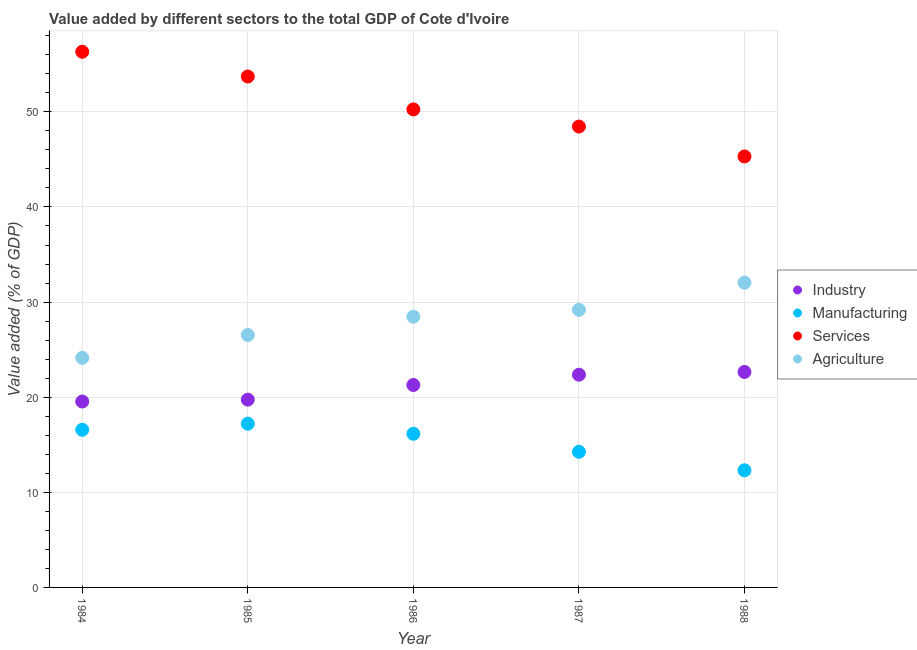What is the value added by industrial sector in 1986?
Your answer should be compact. 21.28. Across all years, what is the maximum value added by manufacturing sector?
Your response must be concise. 17.21. Across all years, what is the minimum value added by services sector?
Offer a very short reply. 45.31. What is the total value added by agricultural sector in the graph?
Your answer should be very brief. 140.36. What is the difference between the value added by services sector in 1985 and that in 1987?
Your answer should be very brief. 5.26. What is the difference between the value added by agricultural sector in 1986 and the value added by services sector in 1984?
Keep it short and to the point. -27.86. What is the average value added by agricultural sector per year?
Make the answer very short. 28.07. In the year 1988, what is the difference between the value added by industrial sector and value added by agricultural sector?
Your response must be concise. -9.39. What is the ratio of the value added by agricultural sector in 1986 to that in 1988?
Your response must be concise. 0.89. Is the difference between the value added by manufacturing sector in 1985 and 1987 greater than the difference between the value added by services sector in 1985 and 1987?
Ensure brevity in your answer.  No. What is the difference between the highest and the second highest value added by agricultural sector?
Your answer should be compact. 2.86. What is the difference between the highest and the lowest value added by industrial sector?
Give a very brief answer. 3.1. In how many years, is the value added by agricultural sector greater than the average value added by agricultural sector taken over all years?
Provide a short and direct response. 3. Is it the case that in every year, the sum of the value added by industrial sector and value added by agricultural sector is greater than the sum of value added by services sector and value added by manufacturing sector?
Your answer should be very brief. No. Is the value added by agricultural sector strictly greater than the value added by manufacturing sector over the years?
Give a very brief answer. Yes. How many dotlines are there?
Provide a succinct answer. 4. Are the values on the major ticks of Y-axis written in scientific E-notation?
Provide a short and direct response. No. Does the graph contain any zero values?
Your answer should be very brief. No. Where does the legend appear in the graph?
Provide a short and direct response. Center right. How are the legend labels stacked?
Provide a succinct answer. Vertical. What is the title of the graph?
Ensure brevity in your answer.  Value added by different sectors to the total GDP of Cote d'Ivoire. What is the label or title of the Y-axis?
Offer a very short reply. Value added (% of GDP). What is the Value added (% of GDP) of Industry in 1984?
Ensure brevity in your answer.  19.55. What is the Value added (% of GDP) of Manufacturing in 1984?
Keep it short and to the point. 16.57. What is the Value added (% of GDP) in Services in 1984?
Ensure brevity in your answer.  56.32. What is the Value added (% of GDP) of Agriculture in 1984?
Your answer should be very brief. 24.13. What is the Value added (% of GDP) in Industry in 1985?
Provide a short and direct response. 19.75. What is the Value added (% of GDP) in Manufacturing in 1985?
Keep it short and to the point. 17.21. What is the Value added (% of GDP) of Services in 1985?
Your answer should be very brief. 53.72. What is the Value added (% of GDP) in Agriculture in 1985?
Your response must be concise. 26.54. What is the Value added (% of GDP) in Industry in 1986?
Make the answer very short. 21.28. What is the Value added (% of GDP) in Manufacturing in 1986?
Your answer should be compact. 16.16. What is the Value added (% of GDP) in Services in 1986?
Make the answer very short. 50.26. What is the Value added (% of GDP) in Agriculture in 1986?
Provide a short and direct response. 28.46. What is the Value added (% of GDP) of Industry in 1987?
Make the answer very short. 22.36. What is the Value added (% of GDP) in Manufacturing in 1987?
Give a very brief answer. 14.26. What is the Value added (% of GDP) of Services in 1987?
Provide a succinct answer. 48.45. What is the Value added (% of GDP) of Agriculture in 1987?
Give a very brief answer. 29.18. What is the Value added (% of GDP) in Industry in 1988?
Keep it short and to the point. 22.65. What is the Value added (% of GDP) of Manufacturing in 1988?
Make the answer very short. 12.32. What is the Value added (% of GDP) of Services in 1988?
Your answer should be very brief. 45.31. What is the Value added (% of GDP) of Agriculture in 1988?
Make the answer very short. 32.04. Across all years, what is the maximum Value added (% of GDP) of Industry?
Provide a succinct answer. 22.65. Across all years, what is the maximum Value added (% of GDP) of Manufacturing?
Your answer should be compact. 17.21. Across all years, what is the maximum Value added (% of GDP) of Services?
Make the answer very short. 56.32. Across all years, what is the maximum Value added (% of GDP) in Agriculture?
Your response must be concise. 32.04. Across all years, what is the minimum Value added (% of GDP) in Industry?
Offer a terse response. 19.55. Across all years, what is the minimum Value added (% of GDP) in Manufacturing?
Provide a succinct answer. 12.32. Across all years, what is the minimum Value added (% of GDP) of Services?
Your response must be concise. 45.31. Across all years, what is the minimum Value added (% of GDP) of Agriculture?
Give a very brief answer. 24.13. What is the total Value added (% of GDP) in Industry in the graph?
Ensure brevity in your answer.  105.59. What is the total Value added (% of GDP) of Manufacturing in the graph?
Ensure brevity in your answer.  76.52. What is the total Value added (% of GDP) of Services in the graph?
Your answer should be very brief. 254.05. What is the total Value added (% of GDP) in Agriculture in the graph?
Your answer should be compact. 140.36. What is the difference between the Value added (% of GDP) in Industry in 1984 and that in 1985?
Your response must be concise. -0.2. What is the difference between the Value added (% of GDP) of Manufacturing in 1984 and that in 1985?
Your answer should be compact. -0.64. What is the difference between the Value added (% of GDP) in Services in 1984 and that in 1985?
Make the answer very short. 2.6. What is the difference between the Value added (% of GDP) in Agriculture in 1984 and that in 1985?
Your response must be concise. -2.4. What is the difference between the Value added (% of GDP) of Industry in 1984 and that in 1986?
Keep it short and to the point. -1.73. What is the difference between the Value added (% of GDP) of Manufacturing in 1984 and that in 1986?
Provide a short and direct response. 0.42. What is the difference between the Value added (% of GDP) of Services in 1984 and that in 1986?
Give a very brief answer. 6.06. What is the difference between the Value added (% of GDP) of Agriculture in 1984 and that in 1986?
Offer a very short reply. -4.33. What is the difference between the Value added (% of GDP) of Industry in 1984 and that in 1987?
Offer a terse response. -2.82. What is the difference between the Value added (% of GDP) in Manufacturing in 1984 and that in 1987?
Offer a terse response. 2.32. What is the difference between the Value added (% of GDP) of Services in 1984 and that in 1987?
Your answer should be compact. 7.86. What is the difference between the Value added (% of GDP) in Agriculture in 1984 and that in 1987?
Make the answer very short. -5.05. What is the difference between the Value added (% of GDP) in Industry in 1984 and that in 1988?
Your answer should be compact. -3.1. What is the difference between the Value added (% of GDP) in Manufacturing in 1984 and that in 1988?
Keep it short and to the point. 4.26. What is the difference between the Value added (% of GDP) of Services in 1984 and that in 1988?
Provide a short and direct response. 11.01. What is the difference between the Value added (% of GDP) in Agriculture in 1984 and that in 1988?
Your response must be concise. -7.9. What is the difference between the Value added (% of GDP) in Industry in 1985 and that in 1986?
Your answer should be compact. -1.54. What is the difference between the Value added (% of GDP) of Manufacturing in 1985 and that in 1986?
Your answer should be compact. 1.05. What is the difference between the Value added (% of GDP) of Services in 1985 and that in 1986?
Your answer should be compact. 3.46. What is the difference between the Value added (% of GDP) of Agriculture in 1985 and that in 1986?
Your response must be concise. -1.92. What is the difference between the Value added (% of GDP) of Industry in 1985 and that in 1987?
Provide a succinct answer. -2.62. What is the difference between the Value added (% of GDP) of Manufacturing in 1985 and that in 1987?
Your response must be concise. 2.95. What is the difference between the Value added (% of GDP) of Services in 1985 and that in 1987?
Your answer should be compact. 5.26. What is the difference between the Value added (% of GDP) in Agriculture in 1985 and that in 1987?
Offer a terse response. -2.64. What is the difference between the Value added (% of GDP) in Industry in 1985 and that in 1988?
Make the answer very short. -2.9. What is the difference between the Value added (% of GDP) in Manufacturing in 1985 and that in 1988?
Your answer should be compact. 4.9. What is the difference between the Value added (% of GDP) in Services in 1985 and that in 1988?
Ensure brevity in your answer.  8.41. What is the difference between the Value added (% of GDP) of Agriculture in 1985 and that in 1988?
Give a very brief answer. -5.5. What is the difference between the Value added (% of GDP) in Industry in 1986 and that in 1987?
Offer a very short reply. -1.08. What is the difference between the Value added (% of GDP) in Manufacturing in 1986 and that in 1987?
Your answer should be very brief. 1.9. What is the difference between the Value added (% of GDP) of Services in 1986 and that in 1987?
Your answer should be very brief. 1.8. What is the difference between the Value added (% of GDP) of Agriculture in 1986 and that in 1987?
Your response must be concise. -0.72. What is the difference between the Value added (% of GDP) in Industry in 1986 and that in 1988?
Make the answer very short. -1.37. What is the difference between the Value added (% of GDP) in Manufacturing in 1986 and that in 1988?
Your response must be concise. 3.84. What is the difference between the Value added (% of GDP) of Services in 1986 and that in 1988?
Give a very brief answer. 4.95. What is the difference between the Value added (% of GDP) in Agriculture in 1986 and that in 1988?
Provide a succinct answer. -3.58. What is the difference between the Value added (% of GDP) of Industry in 1987 and that in 1988?
Your answer should be very brief. -0.29. What is the difference between the Value added (% of GDP) in Manufacturing in 1987 and that in 1988?
Give a very brief answer. 1.94. What is the difference between the Value added (% of GDP) in Services in 1987 and that in 1988?
Keep it short and to the point. 3.14. What is the difference between the Value added (% of GDP) in Agriculture in 1987 and that in 1988?
Your answer should be compact. -2.86. What is the difference between the Value added (% of GDP) of Industry in 1984 and the Value added (% of GDP) of Manufacturing in 1985?
Offer a terse response. 2.34. What is the difference between the Value added (% of GDP) in Industry in 1984 and the Value added (% of GDP) in Services in 1985?
Ensure brevity in your answer.  -34.17. What is the difference between the Value added (% of GDP) in Industry in 1984 and the Value added (% of GDP) in Agriculture in 1985?
Provide a succinct answer. -6.99. What is the difference between the Value added (% of GDP) in Manufacturing in 1984 and the Value added (% of GDP) in Services in 1985?
Give a very brief answer. -37.14. What is the difference between the Value added (% of GDP) in Manufacturing in 1984 and the Value added (% of GDP) in Agriculture in 1985?
Offer a terse response. -9.96. What is the difference between the Value added (% of GDP) of Services in 1984 and the Value added (% of GDP) of Agriculture in 1985?
Your response must be concise. 29.78. What is the difference between the Value added (% of GDP) of Industry in 1984 and the Value added (% of GDP) of Manufacturing in 1986?
Make the answer very short. 3.39. What is the difference between the Value added (% of GDP) of Industry in 1984 and the Value added (% of GDP) of Services in 1986?
Keep it short and to the point. -30.71. What is the difference between the Value added (% of GDP) of Industry in 1984 and the Value added (% of GDP) of Agriculture in 1986?
Your response must be concise. -8.91. What is the difference between the Value added (% of GDP) in Manufacturing in 1984 and the Value added (% of GDP) in Services in 1986?
Your answer should be very brief. -33.68. What is the difference between the Value added (% of GDP) of Manufacturing in 1984 and the Value added (% of GDP) of Agriculture in 1986?
Keep it short and to the point. -11.89. What is the difference between the Value added (% of GDP) of Services in 1984 and the Value added (% of GDP) of Agriculture in 1986?
Ensure brevity in your answer.  27.86. What is the difference between the Value added (% of GDP) of Industry in 1984 and the Value added (% of GDP) of Manufacturing in 1987?
Keep it short and to the point. 5.29. What is the difference between the Value added (% of GDP) of Industry in 1984 and the Value added (% of GDP) of Services in 1987?
Make the answer very short. -28.9. What is the difference between the Value added (% of GDP) in Industry in 1984 and the Value added (% of GDP) in Agriculture in 1987?
Give a very brief answer. -9.63. What is the difference between the Value added (% of GDP) in Manufacturing in 1984 and the Value added (% of GDP) in Services in 1987?
Provide a succinct answer. -31.88. What is the difference between the Value added (% of GDP) of Manufacturing in 1984 and the Value added (% of GDP) of Agriculture in 1987?
Keep it short and to the point. -12.61. What is the difference between the Value added (% of GDP) of Services in 1984 and the Value added (% of GDP) of Agriculture in 1987?
Give a very brief answer. 27.13. What is the difference between the Value added (% of GDP) in Industry in 1984 and the Value added (% of GDP) in Manufacturing in 1988?
Offer a terse response. 7.23. What is the difference between the Value added (% of GDP) of Industry in 1984 and the Value added (% of GDP) of Services in 1988?
Your answer should be compact. -25.76. What is the difference between the Value added (% of GDP) in Industry in 1984 and the Value added (% of GDP) in Agriculture in 1988?
Keep it short and to the point. -12.49. What is the difference between the Value added (% of GDP) in Manufacturing in 1984 and the Value added (% of GDP) in Services in 1988?
Provide a short and direct response. -28.74. What is the difference between the Value added (% of GDP) in Manufacturing in 1984 and the Value added (% of GDP) in Agriculture in 1988?
Provide a succinct answer. -15.47. What is the difference between the Value added (% of GDP) of Services in 1984 and the Value added (% of GDP) of Agriculture in 1988?
Provide a short and direct response. 24.28. What is the difference between the Value added (% of GDP) in Industry in 1985 and the Value added (% of GDP) in Manufacturing in 1986?
Provide a succinct answer. 3.59. What is the difference between the Value added (% of GDP) of Industry in 1985 and the Value added (% of GDP) of Services in 1986?
Provide a succinct answer. -30.51. What is the difference between the Value added (% of GDP) of Industry in 1985 and the Value added (% of GDP) of Agriculture in 1986?
Your response must be concise. -8.72. What is the difference between the Value added (% of GDP) of Manufacturing in 1985 and the Value added (% of GDP) of Services in 1986?
Ensure brevity in your answer.  -33.04. What is the difference between the Value added (% of GDP) in Manufacturing in 1985 and the Value added (% of GDP) in Agriculture in 1986?
Make the answer very short. -11.25. What is the difference between the Value added (% of GDP) in Services in 1985 and the Value added (% of GDP) in Agriculture in 1986?
Your answer should be very brief. 25.25. What is the difference between the Value added (% of GDP) of Industry in 1985 and the Value added (% of GDP) of Manufacturing in 1987?
Keep it short and to the point. 5.49. What is the difference between the Value added (% of GDP) of Industry in 1985 and the Value added (% of GDP) of Services in 1987?
Keep it short and to the point. -28.71. What is the difference between the Value added (% of GDP) in Industry in 1985 and the Value added (% of GDP) in Agriculture in 1987?
Offer a terse response. -9.44. What is the difference between the Value added (% of GDP) in Manufacturing in 1985 and the Value added (% of GDP) in Services in 1987?
Offer a terse response. -31.24. What is the difference between the Value added (% of GDP) of Manufacturing in 1985 and the Value added (% of GDP) of Agriculture in 1987?
Offer a very short reply. -11.97. What is the difference between the Value added (% of GDP) of Services in 1985 and the Value added (% of GDP) of Agriculture in 1987?
Keep it short and to the point. 24.53. What is the difference between the Value added (% of GDP) of Industry in 1985 and the Value added (% of GDP) of Manufacturing in 1988?
Offer a terse response. 7.43. What is the difference between the Value added (% of GDP) of Industry in 1985 and the Value added (% of GDP) of Services in 1988?
Give a very brief answer. -25.56. What is the difference between the Value added (% of GDP) of Industry in 1985 and the Value added (% of GDP) of Agriculture in 1988?
Provide a short and direct response. -12.29. What is the difference between the Value added (% of GDP) in Manufacturing in 1985 and the Value added (% of GDP) in Services in 1988?
Offer a very short reply. -28.1. What is the difference between the Value added (% of GDP) in Manufacturing in 1985 and the Value added (% of GDP) in Agriculture in 1988?
Your response must be concise. -14.83. What is the difference between the Value added (% of GDP) of Services in 1985 and the Value added (% of GDP) of Agriculture in 1988?
Keep it short and to the point. 21.68. What is the difference between the Value added (% of GDP) in Industry in 1986 and the Value added (% of GDP) in Manufacturing in 1987?
Give a very brief answer. 7.02. What is the difference between the Value added (% of GDP) of Industry in 1986 and the Value added (% of GDP) of Services in 1987?
Make the answer very short. -27.17. What is the difference between the Value added (% of GDP) in Industry in 1986 and the Value added (% of GDP) in Agriculture in 1987?
Ensure brevity in your answer.  -7.9. What is the difference between the Value added (% of GDP) of Manufacturing in 1986 and the Value added (% of GDP) of Services in 1987?
Your response must be concise. -32.3. What is the difference between the Value added (% of GDP) in Manufacturing in 1986 and the Value added (% of GDP) in Agriculture in 1987?
Provide a succinct answer. -13.02. What is the difference between the Value added (% of GDP) of Services in 1986 and the Value added (% of GDP) of Agriculture in 1987?
Your response must be concise. 21.07. What is the difference between the Value added (% of GDP) in Industry in 1986 and the Value added (% of GDP) in Manufacturing in 1988?
Offer a very short reply. 8.97. What is the difference between the Value added (% of GDP) in Industry in 1986 and the Value added (% of GDP) in Services in 1988?
Make the answer very short. -24.03. What is the difference between the Value added (% of GDP) in Industry in 1986 and the Value added (% of GDP) in Agriculture in 1988?
Offer a very short reply. -10.76. What is the difference between the Value added (% of GDP) in Manufacturing in 1986 and the Value added (% of GDP) in Services in 1988?
Provide a succinct answer. -29.15. What is the difference between the Value added (% of GDP) in Manufacturing in 1986 and the Value added (% of GDP) in Agriculture in 1988?
Offer a very short reply. -15.88. What is the difference between the Value added (% of GDP) in Services in 1986 and the Value added (% of GDP) in Agriculture in 1988?
Your answer should be compact. 18.22. What is the difference between the Value added (% of GDP) in Industry in 1987 and the Value added (% of GDP) in Manufacturing in 1988?
Your answer should be compact. 10.05. What is the difference between the Value added (% of GDP) in Industry in 1987 and the Value added (% of GDP) in Services in 1988?
Provide a short and direct response. -22.95. What is the difference between the Value added (% of GDP) of Industry in 1987 and the Value added (% of GDP) of Agriculture in 1988?
Your answer should be very brief. -9.67. What is the difference between the Value added (% of GDP) of Manufacturing in 1987 and the Value added (% of GDP) of Services in 1988?
Give a very brief answer. -31.05. What is the difference between the Value added (% of GDP) of Manufacturing in 1987 and the Value added (% of GDP) of Agriculture in 1988?
Your answer should be compact. -17.78. What is the difference between the Value added (% of GDP) in Services in 1987 and the Value added (% of GDP) in Agriculture in 1988?
Provide a short and direct response. 16.41. What is the average Value added (% of GDP) of Industry per year?
Ensure brevity in your answer.  21.12. What is the average Value added (% of GDP) in Manufacturing per year?
Offer a terse response. 15.3. What is the average Value added (% of GDP) in Services per year?
Your answer should be very brief. 50.81. What is the average Value added (% of GDP) of Agriculture per year?
Offer a terse response. 28.07. In the year 1984, what is the difference between the Value added (% of GDP) in Industry and Value added (% of GDP) in Manufacturing?
Provide a succinct answer. 2.97. In the year 1984, what is the difference between the Value added (% of GDP) of Industry and Value added (% of GDP) of Services?
Make the answer very short. -36.77. In the year 1984, what is the difference between the Value added (% of GDP) of Industry and Value added (% of GDP) of Agriculture?
Make the answer very short. -4.59. In the year 1984, what is the difference between the Value added (% of GDP) in Manufacturing and Value added (% of GDP) in Services?
Offer a terse response. -39.74. In the year 1984, what is the difference between the Value added (% of GDP) in Manufacturing and Value added (% of GDP) in Agriculture?
Make the answer very short. -7.56. In the year 1984, what is the difference between the Value added (% of GDP) in Services and Value added (% of GDP) in Agriculture?
Your response must be concise. 32.18. In the year 1985, what is the difference between the Value added (% of GDP) in Industry and Value added (% of GDP) in Manufacturing?
Ensure brevity in your answer.  2.53. In the year 1985, what is the difference between the Value added (% of GDP) in Industry and Value added (% of GDP) in Services?
Make the answer very short. -33.97. In the year 1985, what is the difference between the Value added (% of GDP) in Industry and Value added (% of GDP) in Agriculture?
Keep it short and to the point. -6.79. In the year 1985, what is the difference between the Value added (% of GDP) of Manufacturing and Value added (% of GDP) of Services?
Offer a terse response. -36.51. In the year 1985, what is the difference between the Value added (% of GDP) of Manufacturing and Value added (% of GDP) of Agriculture?
Offer a terse response. -9.33. In the year 1985, what is the difference between the Value added (% of GDP) of Services and Value added (% of GDP) of Agriculture?
Offer a very short reply. 27.18. In the year 1986, what is the difference between the Value added (% of GDP) of Industry and Value added (% of GDP) of Manufacturing?
Offer a terse response. 5.12. In the year 1986, what is the difference between the Value added (% of GDP) of Industry and Value added (% of GDP) of Services?
Offer a terse response. -28.97. In the year 1986, what is the difference between the Value added (% of GDP) of Industry and Value added (% of GDP) of Agriculture?
Ensure brevity in your answer.  -7.18. In the year 1986, what is the difference between the Value added (% of GDP) of Manufacturing and Value added (% of GDP) of Services?
Give a very brief answer. -34.1. In the year 1986, what is the difference between the Value added (% of GDP) of Manufacturing and Value added (% of GDP) of Agriculture?
Offer a terse response. -12.3. In the year 1986, what is the difference between the Value added (% of GDP) of Services and Value added (% of GDP) of Agriculture?
Give a very brief answer. 21.79. In the year 1987, what is the difference between the Value added (% of GDP) in Industry and Value added (% of GDP) in Manufacturing?
Keep it short and to the point. 8.11. In the year 1987, what is the difference between the Value added (% of GDP) in Industry and Value added (% of GDP) in Services?
Keep it short and to the point. -26.09. In the year 1987, what is the difference between the Value added (% of GDP) in Industry and Value added (% of GDP) in Agriculture?
Your answer should be very brief. -6.82. In the year 1987, what is the difference between the Value added (% of GDP) in Manufacturing and Value added (% of GDP) in Services?
Your answer should be very brief. -34.19. In the year 1987, what is the difference between the Value added (% of GDP) of Manufacturing and Value added (% of GDP) of Agriculture?
Your response must be concise. -14.92. In the year 1987, what is the difference between the Value added (% of GDP) of Services and Value added (% of GDP) of Agriculture?
Provide a succinct answer. 19.27. In the year 1988, what is the difference between the Value added (% of GDP) in Industry and Value added (% of GDP) in Manufacturing?
Make the answer very short. 10.34. In the year 1988, what is the difference between the Value added (% of GDP) of Industry and Value added (% of GDP) of Services?
Provide a short and direct response. -22.66. In the year 1988, what is the difference between the Value added (% of GDP) of Industry and Value added (% of GDP) of Agriculture?
Ensure brevity in your answer.  -9.39. In the year 1988, what is the difference between the Value added (% of GDP) in Manufacturing and Value added (% of GDP) in Services?
Ensure brevity in your answer.  -32.99. In the year 1988, what is the difference between the Value added (% of GDP) of Manufacturing and Value added (% of GDP) of Agriculture?
Give a very brief answer. -19.72. In the year 1988, what is the difference between the Value added (% of GDP) of Services and Value added (% of GDP) of Agriculture?
Make the answer very short. 13.27. What is the ratio of the Value added (% of GDP) of Industry in 1984 to that in 1985?
Provide a succinct answer. 0.99. What is the ratio of the Value added (% of GDP) of Services in 1984 to that in 1985?
Offer a terse response. 1.05. What is the ratio of the Value added (% of GDP) in Agriculture in 1984 to that in 1985?
Provide a short and direct response. 0.91. What is the ratio of the Value added (% of GDP) of Industry in 1984 to that in 1986?
Make the answer very short. 0.92. What is the ratio of the Value added (% of GDP) in Manufacturing in 1984 to that in 1986?
Your answer should be compact. 1.03. What is the ratio of the Value added (% of GDP) in Services in 1984 to that in 1986?
Ensure brevity in your answer.  1.12. What is the ratio of the Value added (% of GDP) in Agriculture in 1984 to that in 1986?
Offer a terse response. 0.85. What is the ratio of the Value added (% of GDP) in Industry in 1984 to that in 1987?
Offer a very short reply. 0.87. What is the ratio of the Value added (% of GDP) in Manufacturing in 1984 to that in 1987?
Give a very brief answer. 1.16. What is the ratio of the Value added (% of GDP) in Services in 1984 to that in 1987?
Give a very brief answer. 1.16. What is the ratio of the Value added (% of GDP) in Agriculture in 1984 to that in 1987?
Give a very brief answer. 0.83. What is the ratio of the Value added (% of GDP) of Industry in 1984 to that in 1988?
Your answer should be compact. 0.86. What is the ratio of the Value added (% of GDP) in Manufacturing in 1984 to that in 1988?
Your response must be concise. 1.35. What is the ratio of the Value added (% of GDP) of Services in 1984 to that in 1988?
Provide a short and direct response. 1.24. What is the ratio of the Value added (% of GDP) in Agriculture in 1984 to that in 1988?
Provide a succinct answer. 0.75. What is the ratio of the Value added (% of GDP) in Industry in 1985 to that in 1986?
Offer a very short reply. 0.93. What is the ratio of the Value added (% of GDP) of Manufacturing in 1985 to that in 1986?
Offer a terse response. 1.07. What is the ratio of the Value added (% of GDP) of Services in 1985 to that in 1986?
Ensure brevity in your answer.  1.07. What is the ratio of the Value added (% of GDP) in Agriculture in 1985 to that in 1986?
Offer a very short reply. 0.93. What is the ratio of the Value added (% of GDP) in Industry in 1985 to that in 1987?
Ensure brevity in your answer.  0.88. What is the ratio of the Value added (% of GDP) of Manufacturing in 1985 to that in 1987?
Make the answer very short. 1.21. What is the ratio of the Value added (% of GDP) in Services in 1985 to that in 1987?
Offer a terse response. 1.11. What is the ratio of the Value added (% of GDP) of Agriculture in 1985 to that in 1987?
Your answer should be very brief. 0.91. What is the ratio of the Value added (% of GDP) in Industry in 1985 to that in 1988?
Offer a terse response. 0.87. What is the ratio of the Value added (% of GDP) of Manufacturing in 1985 to that in 1988?
Offer a very short reply. 1.4. What is the ratio of the Value added (% of GDP) in Services in 1985 to that in 1988?
Give a very brief answer. 1.19. What is the ratio of the Value added (% of GDP) in Agriculture in 1985 to that in 1988?
Your answer should be very brief. 0.83. What is the ratio of the Value added (% of GDP) in Industry in 1986 to that in 1987?
Offer a terse response. 0.95. What is the ratio of the Value added (% of GDP) in Manufacturing in 1986 to that in 1987?
Provide a short and direct response. 1.13. What is the ratio of the Value added (% of GDP) in Services in 1986 to that in 1987?
Give a very brief answer. 1.04. What is the ratio of the Value added (% of GDP) of Agriculture in 1986 to that in 1987?
Your response must be concise. 0.98. What is the ratio of the Value added (% of GDP) in Industry in 1986 to that in 1988?
Provide a short and direct response. 0.94. What is the ratio of the Value added (% of GDP) of Manufacturing in 1986 to that in 1988?
Provide a succinct answer. 1.31. What is the ratio of the Value added (% of GDP) of Services in 1986 to that in 1988?
Your answer should be very brief. 1.11. What is the ratio of the Value added (% of GDP) in Agriculture in 1986 to that in 1988?
Offer a terse response. 0.89. What is the ratio of the Value added (% of GDP) of Industry in 1987 to that in 1988?
Make the answer very short. 0.99. What is the ratio of the Value added (% of GDP) of Manufacturing in 1987 to that in 1988?
Give a very brief answer. 1.16. What is the ratio of the Value added (% of GDP) of Services in 1987 to that in 1988?
Ensure brevity in your answer.  1.07. What is the ratio of the Value added (% of GDP) of Agriculture in 1987 to that in 1988?
Offer a very short reply. 0.91. What is the difference between the highest and the second highest Value added (% of GDP) in Industry?
Provide a short and direct response. 0.29. What is the difference between the highest and the second highest Value added (% of GDP) of Manufacturing?
Make the answer very short. 0.64. What is the difference between the highest and the second highest Value added (% of GDP) of Services?
Keep it short and to the point. 2.6. What is the difference between the highest and the second highest Value added (% of GDP) of Agriculture?
Provide a succinct answer. 2.86. What is the difference between the highest and the lowest Value added (% of GDP) in Industry?
Ensure brevity in your answer.  3.1. What is the difference between the highest and the lowest Value added (% of GDP) in Manufacturing?
Your answer should be compact. 4.9. What is the difference between the highest and the lowest Value added (% of GDP) in Services?
Give a very brief answer. 11.01. What is the difference between the highest and the lowest Value added (% of GDP) in Agriculture?
Ensure brevity in your answer.  7.9. 